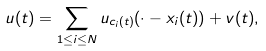Convert formula to latex. <formula><loc_0><loc_0><loc_500><loc_500>u ( t ) = \sum _ { 1 \leq i \leq N } u _ { c _ { i } ( t ) } ( \cdot - x _ { i } ( t ) ) + v ( t ) ,</formula> 